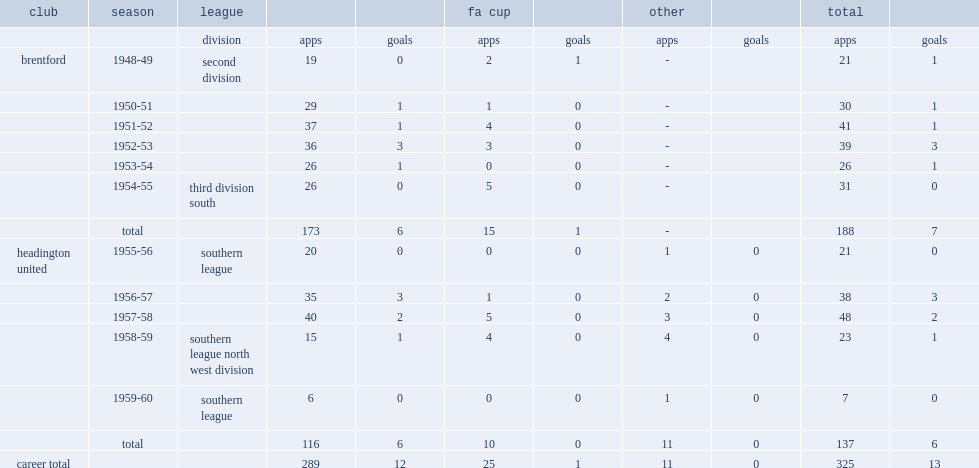How many appearances did harper make in the league for brentford? 173.0. 